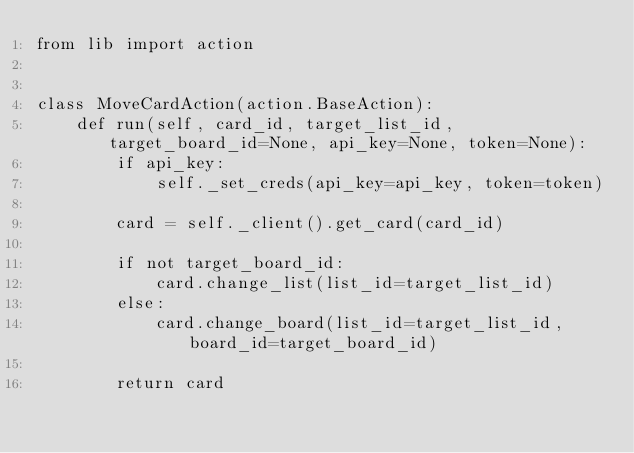Convert code to text. <code><loc_0><loc_0><loc_500><loc_500><_Python_>from lib import action


class MoveCardAction(action.BaseAction):
    def run(self, card_id, target_list_id, target_board_id=None, api_key=None, token=None):
        if api_key:
            self._set_creds(api_key=api_key, token=token)

        card = self._client().get_card(card_id)

        if not target_board_id:
            card.change_list(list_id=target_list_id)
        else:
            card.change_board(list_id=target_list_id, board_id=target_board_id)

        return card
</code> 